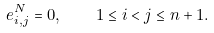Convert formula to latex. <formula><loc_0><loc_0><loc_500><loc_500>e _ { i , j } ^ { N } = 0 , \quad 1 \leq i < j \leq n + 1 .</formula> 